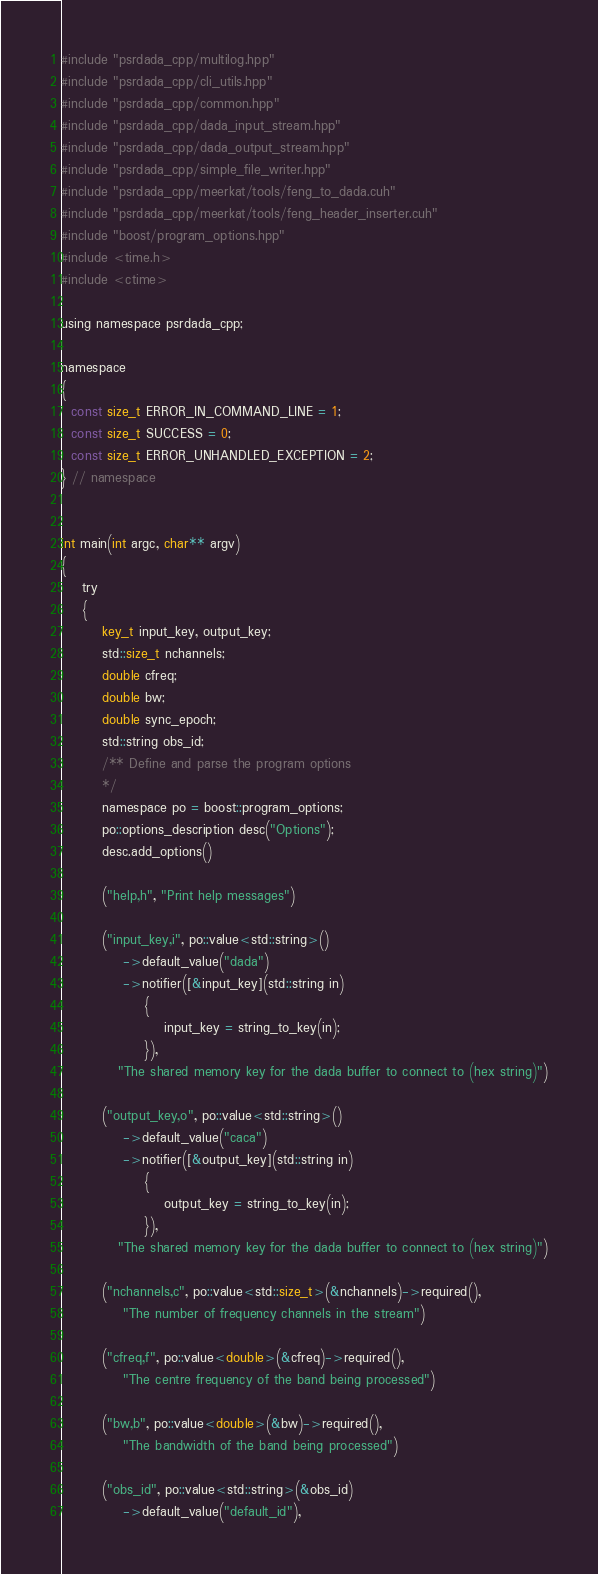<code> <loc_0><loc_0><loc_500><loc_500><_Cuda_>#include "psrdada_cpp/multilog.hpp"
#include "psrdada_cpp/cli_utils.hpp"
#include "psrdada_cpp/common.hpp"
#include "psrdada_cpp/dada_input_stream.hpp"
#include "psrdada_cpp/dada_output_stream.hpp"
#include "psrdada_cpp/simple_file_writer.hpp"
#include "psrdada_cpp/meerkat/tools/feng_to_dada.cuh"
#include "psrdada_cpp/meerkat/tools/feng_header_inserter.cuh"
#include "boost/program_options.hpp"
#include <time.h>
#include <ctime>

using namespace psrdada_cpp;

namespace
{
  const size_t ERROR_IN_COMMAND_LINE = 1;
  const size_t SUCCESS = 0;
  const size_t ERROR_UNHANDLED_EXCEPTION = 2;
} // namespace


int main(int argc, char** argv)
{
    try
    {
        key_t input_key, output_key;
        std::size_t nchannels;
        double cfreq;
        double bw;
        double sync_epoch;
        std::string obs_id;
        /** Define and parse the program options
        */
        namespace po = boost::program_options;
        po::options_description desc("Options");
        desc.add_options()

        ("help,h", "Print help messages")

        ("input_key,i", po::value<std::string>()
            ->default_value("dada")
            ->notifier([&input_key](std::string in)
                {
                    input_key = string_to_key(in);
                }),
           "The shared memory key for the dada buffer to connect to (hex string)")

        ("output_key,o", po::value<std::string>()
            ->default_value("caca")
            ->notifier([&output_key](std::string in)
                {
                    output_key = string_to_key(in);
                }),
           "The shared memory key for the dada buffer to connect to (hex string)")

        ("nchannels,c", po::value<std::size_t>(&nchannels)->required(),
            "The number of frequency channels in the stream")

        ("cfreq,f", po::value<double>(&cfreq)->required(),
            "The centre frequency of the band being processed")

        ("bw,b", po::value<double>(&bw)->required(),
            "The bandwidth of the band being processed")

        ("obs_id", po::value<std::string>(&obs_id)
            ->default_value("default_id"),</code> 